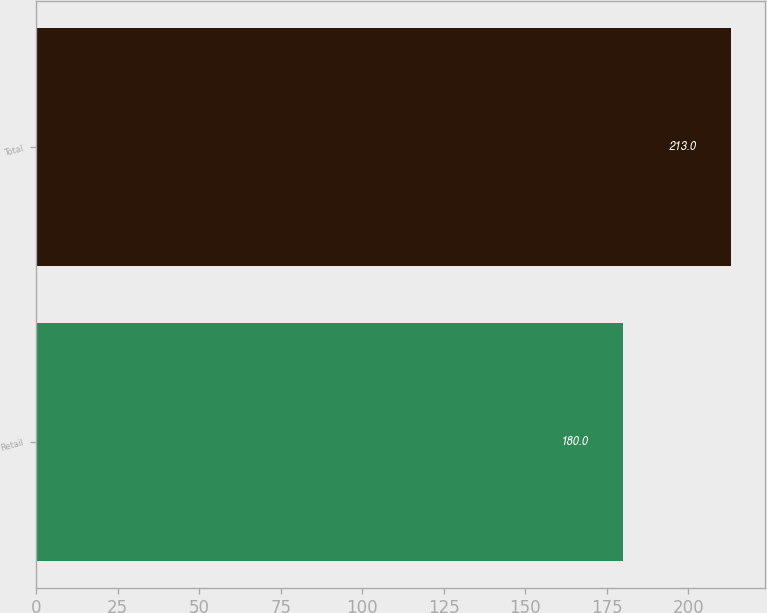<chart> <loc_0><loc_0><loc_500><loc_500><bar_chart><fcel>Retail<fcel>Total<nl><fcel>180<fcel>213<nl></chart> 